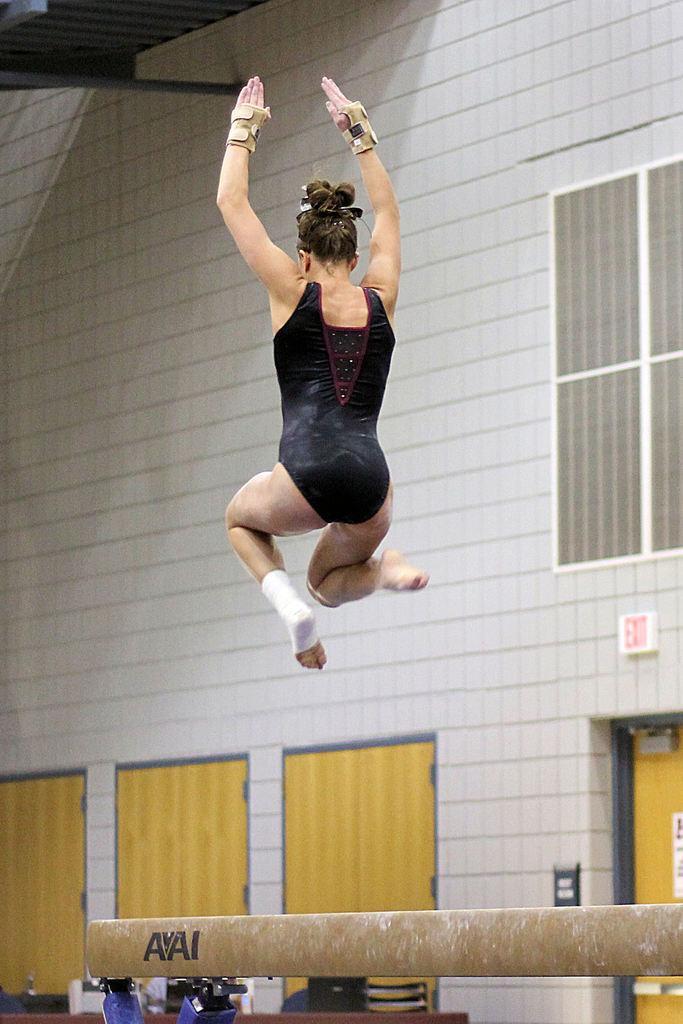Describe this image in one or two sentences. In this image we can see a woman wearing a dress and gloves. In the background, we can see the pole, group of doors, windows and a metal railing. 